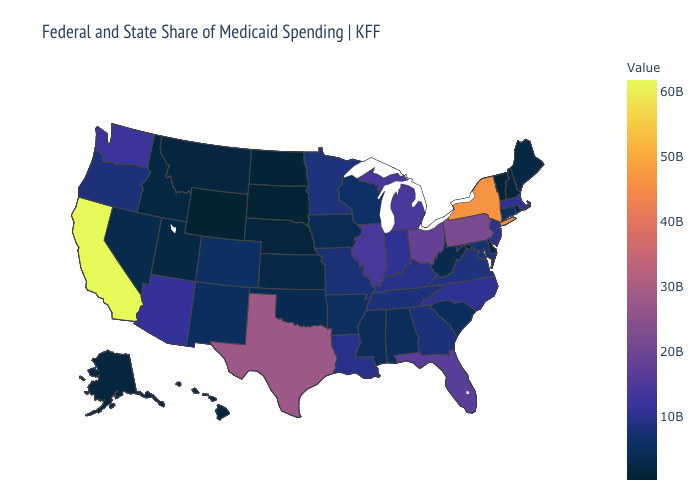Among the states that border Colorado , which have the highest value?
Keep it brief. Arizona. Does Nebraska have the highest value in the USA?
Quick response, please. No. Which states have the lowest value in the USA?
Quick response, please. Wyoming. Among the states that border Arkansas , which have the lowest value?
Keep it brief. Oklahoma. Is the legend a continuous bar?
Quick response, please. Yes. Which states have the highest value in the USA?
Concise answer only. California. Which states have the highest value in the USA?
Concise answer only. California. 